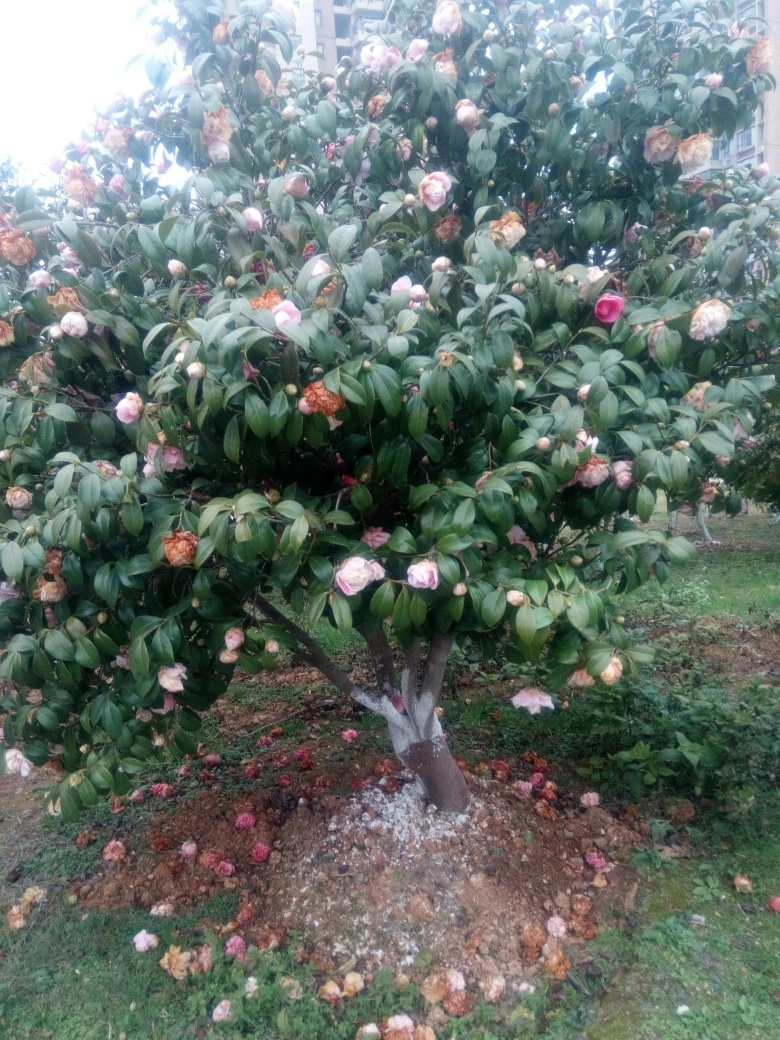What is the overall sharpness like in this image?
A. Soft
B. Excellent
C. Unfocused
Answer with the option's letter from the given choices directly.
 The image appears to have a reasonable level of sharpness, with details in the tree and flowers being quite discernible, indicating a satisfactory capture quality. While it's not at the peak of excellence, most likely due to lighting conditions or slight camera shake, it's definitely not unfocused. Thus, the most appropriate choice would be 'B. Excellent', although 'A. Soft' might be a more fitting description if considering the gentle texture of the petals and leaves. 